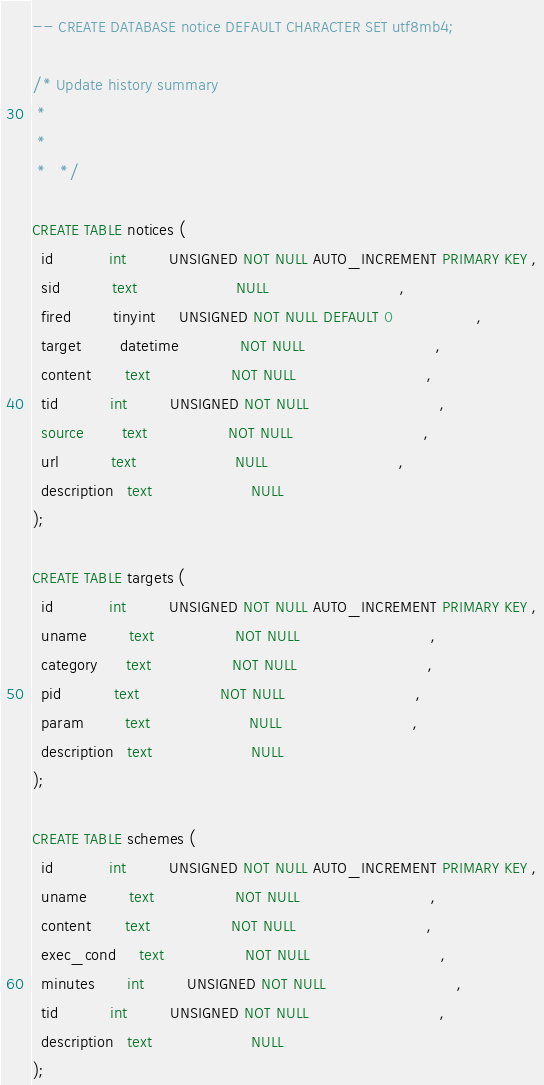<code> <loc_0><loc_0><loc_500><loc_500><_SQL_>-- CREATE DATABASE notice DEFAULT CHARACTER SET utf8mb4;

/* Update history summary
 *
 *
 *   */

CREATE TABLE notices (
  id            int         UNSIGNED NOT NULL AUTO_INCREMENT PRIMARY KEY ,
  sid           text                     NULL                            ,
  fired         tinyint     UNSIGNED NOT NULL DEFAULT 0                  ,
  target        datetime             NOT NULL                            ,
  content       text                 NOT NULL                            ,
  tid           int         UNSIGNED NOT NULL                            ,
  source        text                 NOT NULL                            ,
  url           text                     NULL                            ,
  description   text                     NULL                            
);

CREATE TABLE targets (
  id            int         UNSIGNED NOT NULL AUTO_INCREMENT PRIMARY KEY ,
  uname         text                 NOT NULL                            ,
  category      text                 NOT NULL                            ,
  pid           text                 NOT NULL                            ,
  param         text                     NULL                            ,
  description   text                     NULL                            
);

CREATE TABLE schemes (
  id            int         UNSIGNED NOT NULL AUTO_INCREMENT PRIMARY KEY ,
  uname         text                 NOT NULL                            ,
  content       text                 NOT NULL                            ,
  exec_cond     text                 NOT NULL                            ,
  minutes       int         UNSIGNED NOT NULL                            ,
  tid           int         UNSIGNED NOT NULL                            ,
  description   text                     NULL                            
);

</code> 